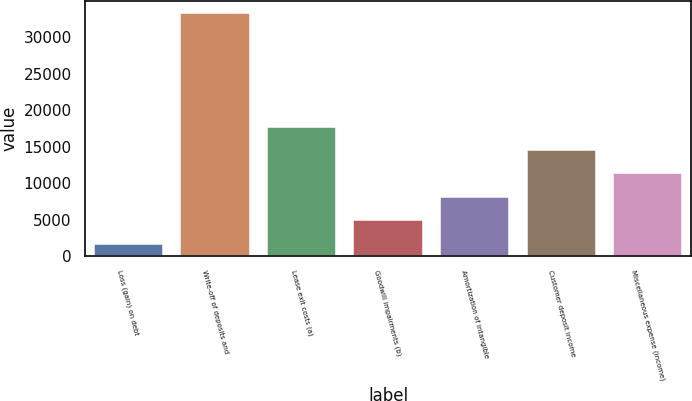Convert chart. <chart><loc_0><loc_0><loc_500><loc_500><bar_chart><fcel>Loss (gain) on debt<fcel>Write-off of deposits and<fcel>Lease exit costs (a)<fcel>Goodwill impairments (b)<fcel>Amortization of intangible<fcel>Customer deposit income<fcel>Miscellaneous expense (income)<nl><fcel>1594<fcel>33309<fcel>17665.5<fcel>4954<fcel>8151<fcel>14494<fcel>11322.5<nl></chart> 